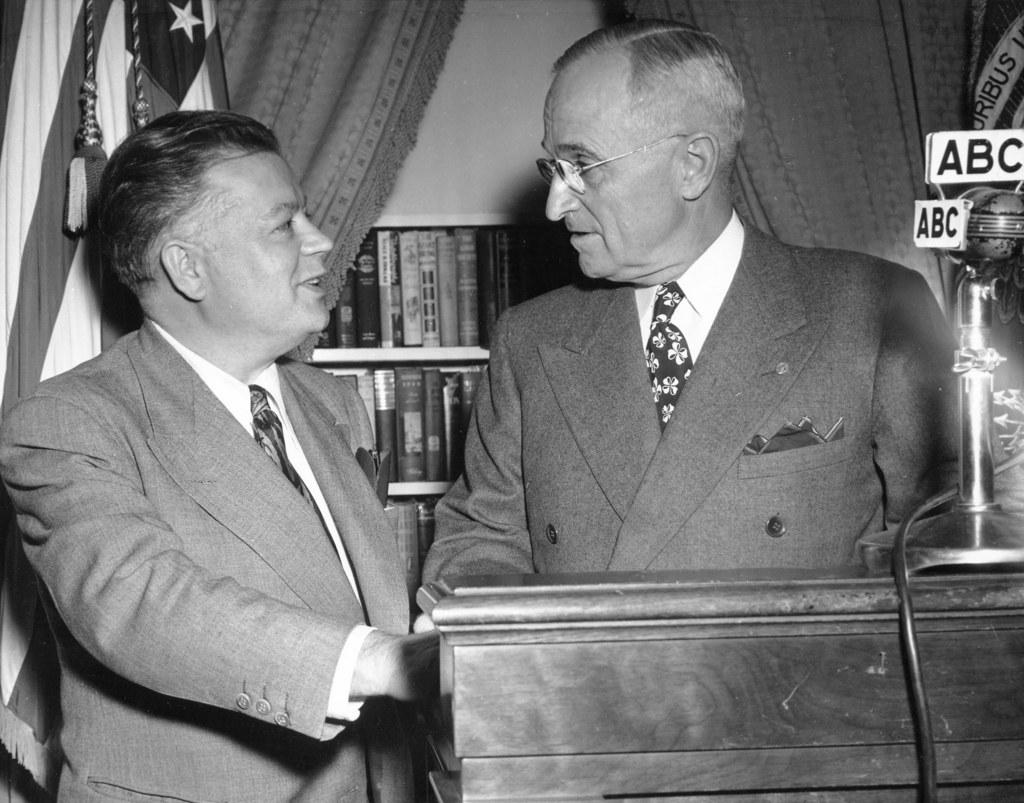<image>
Give a short and clear explanation of the subsequent image. Two men stand in front of a microphone that reads "ABC." 